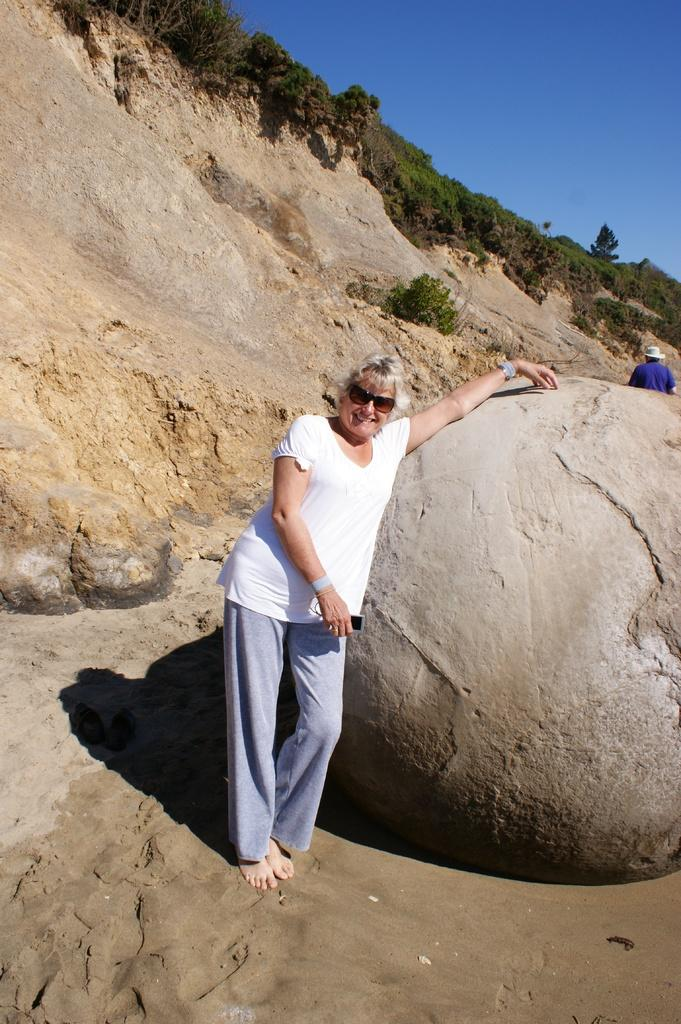What type of natural elements can be seen in the image? There are trees in the image. What non-living object is present in the image? There is a rock in the image. Who is present in the image? There is a woman standing in the image. What accessory is the woman wearing? The woman is wearing sunglasses. What colors can be seen in the sky in the image? The sky is black and blue in the image. What is the price of the self-rewarding device in the image? There is no self-rewarding device present in the image. What type of reward can be seen in the image? There is no reward present in the image. 